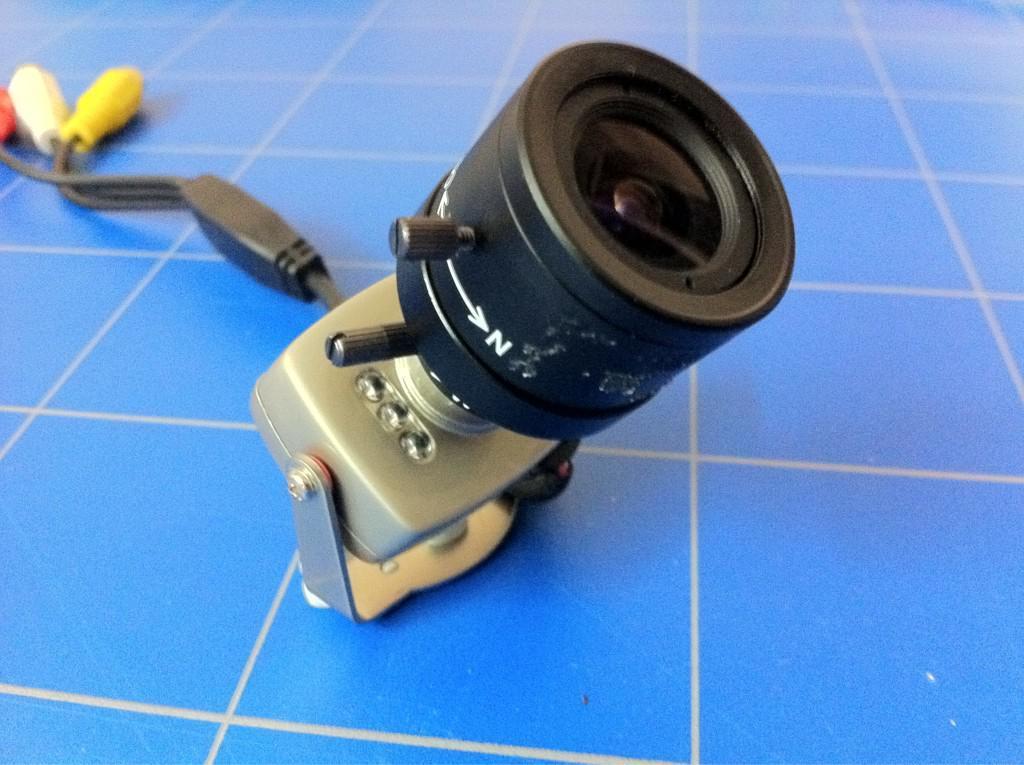Describe this image in one or two sentences. In this image I can see camera and red,white and yellow color pins. The camera is on the blue color floor. 